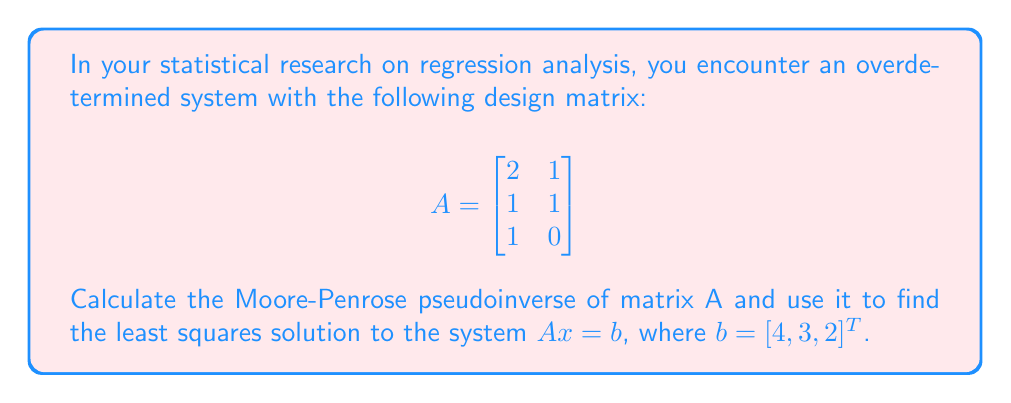Solve this math problem. To find the Moore-Penrose pseudoinverse and solve the overdetermined system, we'll follow these steps:

1) Calculate $A^T$:
   $$A^T = \begin{bmatrix}
   2 & 1 & 1 \\
   1 & 1 & 0
   \end{bmatrix}$$

2) Calculate $A^TA$:
   $$A^TA = \begin{bmatrix}
   2 & 1 & 1 \\
   1 & 1 & 0
   \end{bmatrix} \begin{bmatrix}
   2 & 1 \\
   1 & 1 \\
   1 & 0
   \end{bmatrix} = \begin{bmatrix}
   6 & 3 \\
   3 & 2
   \end{bmatrix}$$

3) Find $(A^TA)^{-1}$:
   $$\det(A^TA) = 6(2) - 3(3) = 3$$
   $$(A^TA)^{-1} = \frac{1}{3} \begin{bmatrix}
   2 & -3 \\
   -3 & 6
   \end{bmatrix}$$

4) Calculate the pseudoinverse $A^+$:
   $$A^+ = (A^TA)^{-1}A^T = \frac{1}{3} \begin{bmatrix}
   2 & -3 \\
   -3 & 6
   \end{bmatrix} \begin{bmatrix}
   2 & 1 & 1 \\
   1 & 1 & 0
   \end{bmatrix}$$

   $$A^+ = \frac{1}{3} \begin{bmatrix}
   1 & -1 & 2 \\
   0 & 1 & -1
   \end{bmatrix}$$

5) Solve for $x$ using $x = A^+b$:
   $$x = \frac{1}{3} \begin{bmatrix}
   1 & -1 & 2 \\
   0 & 1 & -1
   \end{bmatrix} \begin{bmatrix}
   4 \\
   3 \\
   2
   \end{bmatrix}$$

   $$x = \frac{1}{3} \begin{bmatrix}
   1(4) + (-1)(3) + 2(2) \\
   0(4) + 1(3) + (-1)(2)
   \end{bmatrix} = \begin{bmatrix}
   5/3 \\
   1/3
   \end{bmatrix}$$
Answer: $A^+ = \frac{1}{3} \begin{bmatrix}
1 & -1 & 2 \\
0 & 1 & -1
\end{bmatrix}$, $x = \begin{bmatrix}
5/3 \\
1/3
\end{bmatrix}$ 